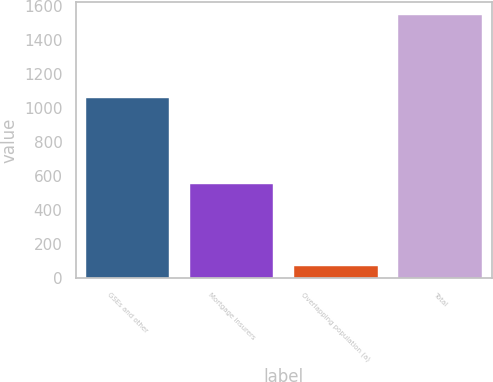Convert chart. <chart><loc_0><loc_0><loc_500><loc_500><bar_chart><fcel>GSEs and other<fcel>Mortgage insurers<fcel>Overlapping population (a)<fcel>Total<nl><fcel>1063<fcel>556<fcel>69<fcel>1550<nl></chart> 